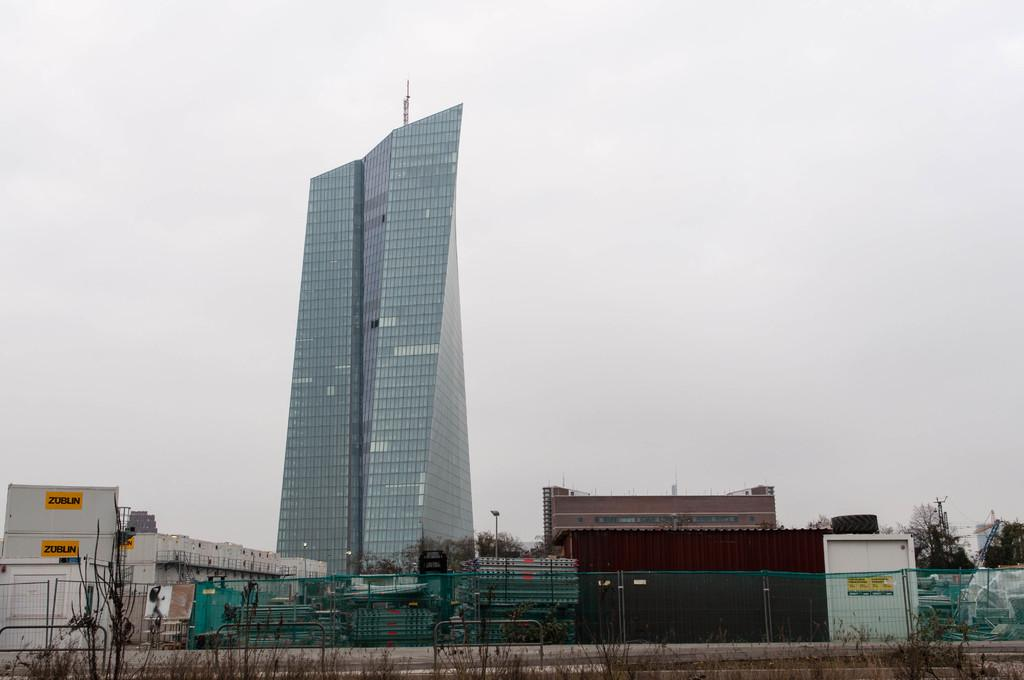What type of structure is the main subject of the image? There is a tall building in the image. What material is the building made of? The building is made of glass pieces. What can be seen around the building? The building is surrounded by small houses. What type of vegetation is near the building? Trees are present near the building. What is the writer's feeling about the building in the image? There is no writer mentioned in the image, and therefore no feelings can be attributed to them. 